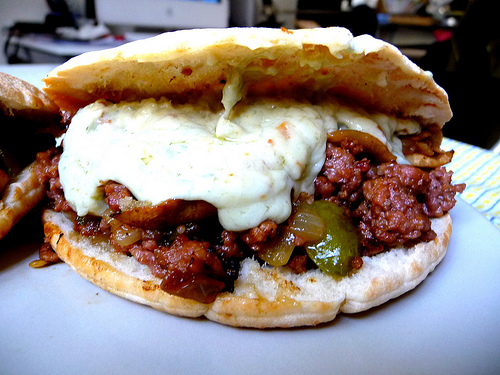<image>
Is there a meat on the table? No. The meat is not positioned on the table. They may be near each other, but the meat is not supported by or resting on top of the table. Is the bread under the filling? Yes. The bread is positioned underneath the filling, with the filling above it in the vertical space. 